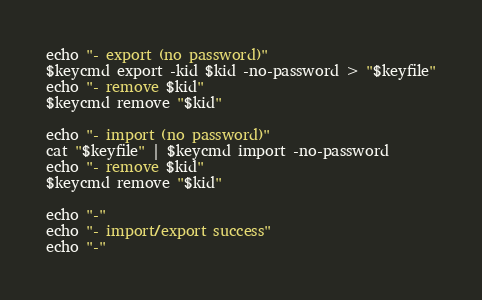<code> <loc_0><loc_0><loc_500><loc_500><_Bash_>
echo "- export (no password)"
$keycmd export -kid $kid -no-password > "$keyfile"
echo "- remove $kid"
$keycmd remove "$kid"

echo "- import (no password)"
cat "$keyfile" | $keycmd import -no-password
echo "- remove $kid"
$keycmd remove "$kid"

echo "-"
echo "- import/export success"
echo "-"</code> 